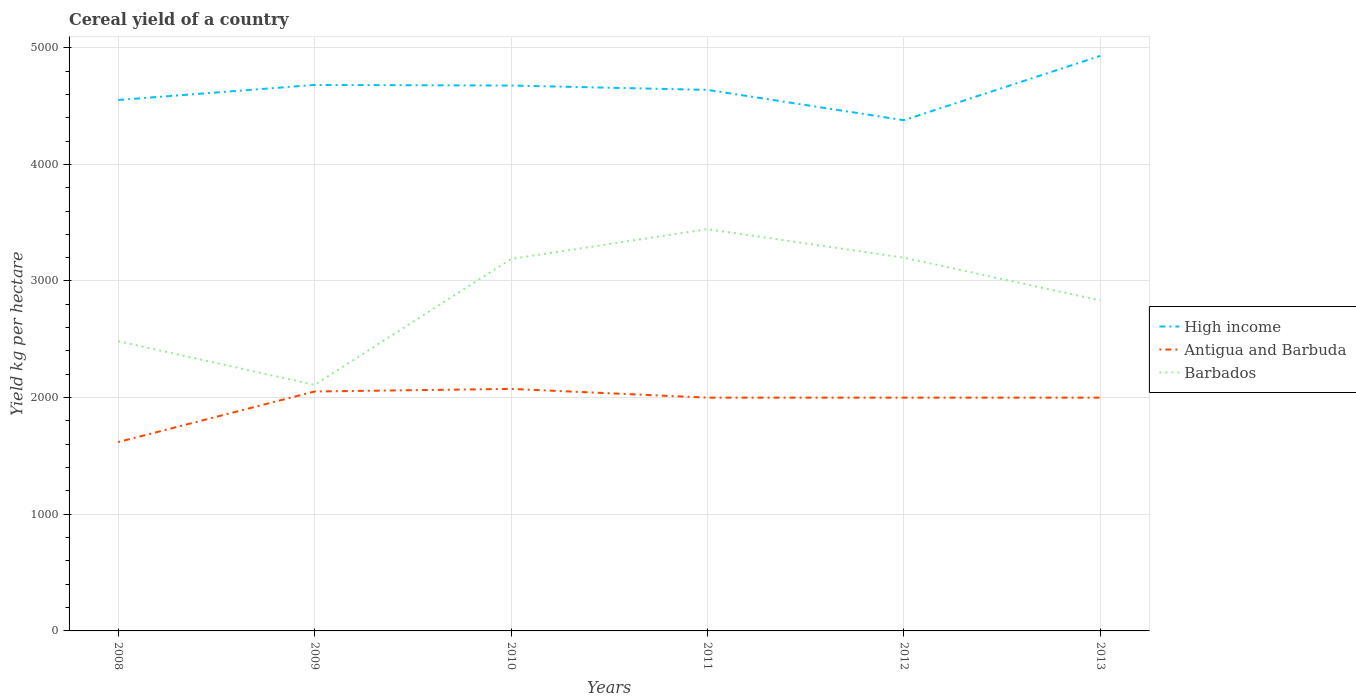How many different coloured lines are there?
Your answer should be very brief. 3. Is the number of lines equal to the number of legend labels?
Make the answer very short. Yes. Across all years, what is the maximum total cereal yield in Antigua and Barbuda?
Provide a succinct answer. 1619.05. In which year was the total cereal yield in High income maximum?
Provide a succinct answer. 2012. What is the total total cereal yield in High income in the graph?
Your answer should be very brief. 302.4. What is the difference between the highest and the second highest total cereal yield in Barbados?
Offer a terse response. 1335.07. How many lines are there?
Make the answer very short. 3. How many years are there in the graph?
Your answer should be compact. 6. What is the difference between two consecutive major ticks on the Y-axis?
Keep it short and to the point. 1000. Does the graph contain any zero values?
Your answer should be compact. No. How many legend labels are there?
Offer a terse response. 3. How are the legend labels stacked?
Your answer should be very brief. Vertical. What is the title of the graph?
Ensure brevity in your answer.  Cereal yield of a country. What is the label or title of the X-axis?
Your answer should be very brief. Years. What is the label or title of the Y-axis?
Offer a very short reply. Yield kg per hectare. What is the Yield kg per hectare in High income in 2008?
Your answer should be very brief. 4551.76. What is the Yield kg per hectare of Antigua and Barbuda in 2008?
Offer a very short reply. 1619.05. What is the Yield kg per hectare of Barbados in 2008?
Give a very brief answer. 2484.21. What is the Yield kg per hectare in High income in 2009?
Offer a very short reply. 4680.84. What is the Yield kg per hectare in Antigua and Barbuda in 2009?
Your answer should be very brief. 2052.63. What is the Yield kg per hectare in Barbados in 2009?
Your response must be concise. 2109.38. What is the Yield kg per hectare in High income in 2010?
Provide a short and direct response. 4675.68. What is the Yield kg per hectare in Antigua and Barbuda in 2010?
Provide a short and direct response. 2075. What is the Yield kg per hectare of Barbados in 2010?
Ensure brevity in your answer.  3188.89. What is the Yield kg per hectare in High income in 2011?
Your answer should be very brief. 4638.49. What is the Yield kg per hectare in Antigua and Barbuda in 2011?
Provide a succinct answer. 2000. What is the Yield kg per hectare in Barbados in 2011?
Offer a terse response. 3444.44. What is the Yield kg per hectare in High income in 2012?
Offer a terse response. 4378.44. What is the Yield kg per hectare in Barbados in 2012?
Give a very brief answer. 3200. What is the Yield kg per hectare of High income in 2013?
Make the answer very short. 4929.93. What is the Yield kg per hectare in Antigua and Barbuda in 2013?
Provide a succinct answer. 2000. What is the Yield kg per hectare in Barbados in 2013?
Your response must be concise. 2833.33. Across all years, what is the maximum Yield kg per hectare of High income?
Your response must be concise. 4929.93. Across all years, what is the maximum Yield kg per hectare in Antigua and Barbuda?
Make the answer very short. 2075. Across all years, what is the maximum Yield kg per hectare of Barbados?
Give a very brief answer. 3444.44. Across all years, what is the minimum Yield kg per hectare of High income?
Provide a succinct answer. 4378.44. Across all years, what is the minimum Yield kg per hectare in Antigua and Barbuda?
Provide a succinct answer. 1619.05. Across all years, what is the minimum Yield kg per hectare in Barbados?
Provide a succinct answer. 2109.38. What is the total Yield kg per hectare in High income in the graph?
Your response must be concise. 2.79e+04. What is the total Yield kg per hectare of Antigua and Barbuda in the graph?
Make the answer very short. 1.17e+04. What is the total Yield kg per hectare of Barbados in the graph?
Make the answer very short. 1.73e+04. What is the difference between the Yield kg per hectare of High income in 2008 and that in 2009?
Make the answer very short. -129.08. What is the difference between the Yield kg per hectare of Antigua and Barbuda in 2008 and that in 2009?
Offer a very short reply. -433.58. What is the difference between the Yield kg per hectare of Barbados in 2008 and that in 2009?
Your response must be concise. 374.84. What is the difference between the Yield kg per hectare in High income in 2008 and that in 2010?
Your answer should be compact. -123.92. What is the difference between the Yield kg per hectare of Antigua and Barbuda in 2008 and that in 2010?
Offer a terse response. -455.95. What is the difference between the Yield kg per hectare in Barbados in 2008 and that in 2010?
Your response must be concise. -704.68. What is the difference between the Yield kg per hectare in High income in 2008 and that in 2011?
Provide a short and direct response. -86.73. What is the difference between the Yield kg per hectare of Antigua and Barbuda in 2008 and that in 2011?
Your answer should be very brief. -380.95. What is the difference between the Yield kg per hectare in Barbados in 2008 and that in 2011?
Your response must be concise. -960.23. What is the difference between the Yield kg per hectare in High income in 2008 and that in 2012?
Offer a terse response. 173.32. What is the difference between the Yield kg per hectare in Antigua and Barbuda in 2008 and that in 2012?
Your response must be concise. -380.95. What is the difference between the Yield kg per hectare in Barbados in 2008 and that in 2012?
Make the answer very short. -715.79. What is the difference between the Yield kg per hectare in High income in 2008 and that in 2013?
Offer a very short reply. -378.17. What is the difference between the Yield kg per hectare in Antigua and Barbuda in 2008 and that in 2013?
Make the answer very short. -380.95. What is the difference between the Yield kg per hectare of Barbados in 2008 and that in 2013?
Keep it short and to the point. -349.12. What is the difference between the Yield kg per hectare of High income in 2009 and that in 2010?
Your answer should be compact. 5.16. What is the difference between the Yield kg per hectare in Antigua and Barbuda in 2009 and that in 2010?
Your answer should be very brief. -22.37. What is the difference between the Yield kg per hectare in Barbados in 2009 and that in 2010?
Give a very brief answer. -1079.51. What is the difference between the Yield kg per hectare in High income in 2009 and that in 2011?
Make the answer very short. 42.35. What is the difference between the Yield kg per hectare in Antigua and Barbuda in 2009 and that in 2011?
Offer a terse response. 52.63. What is the difference between the Yield kg per hectare in Barbados in 2009 and that in 2011?
Your answer should be very brief. -1335.07. What is the difference between the Yield kg per hectare in High income in 2009 and that in 2012?
Keep it short and to the point. 302.4. What is the difference between the Yield kg per hectare in Antigua and Barbuda in 2009 and that in 2012?
Ensure brevity in your answer.  52.63. What is the difference between the Yield kg per hectare of Barbados in 2009 and that in 2012?
Keep it short and to the point. -1090.62. What is the difference between the Yield kg per hectare of High income in 2009 and that in 2013?
Offer a very short reply. -249.09. What is the difference between the Yield kg per hectare in Antigua and Barbuda in 2009 and that in 2013?
Provide a short and direct response. 52.63. What is the difference between the Yield kg per hectare in Barbados in 2009 and that in 2013?
Offer a very short reply. -723.96. What is the difference between the Yield kg per hectare of High income in 2010 and that in 2011?
Ensure brevity in your answer.  37.19. What is the difference between the Yield kg per hectare of Antigua and Barbuda in 2010 and that in 2011?
Make the answer very short. 75. What is the difference between the Yield kg per hectare in Barbados in 2010 and that in 2011?
Offer a very short reply. -255.56. What is the difference between the Yield kg per hectare in High income in 2010 and that in 2012?
Provide a short and direct response. 297.24. What is the difference between the Yield kg per hectare in Barbados in 2010 and that in 2012?
Your answer should be compact. -11.11. What is the difference between the Yield kg per hectare in High income in 2010 and that in 2013?
Your answer should be very brief. -254.25. What is the difference between the Yield kg per hectare in Barbados in 2010 and that in 2013?
Your response must be concise. 355.56. What is the difference between the Yield kg per hectare in High income in 2011 and that in 2012?
Provide a succinct answer. 260.05. What is the difference between the Yield kg per hectare of Antigua and Barbuda in 2011 and that in 2012?
Provide a short and direct response. 0. What is the difference between the Yield kg per hectare in Barbados in 2011 and that in 2012?
Offer a terse response. 244.44. What is the difference between the Yield kg per hectare in High income in 2011 and that in 2013?
Offer a terse response. -291.44. What is the difference between the Yield kg per hectare of Barbados in 2011 and that in 2013?
Keep it short and to the point. 611.11. What is the difference between the Yield kg per hectare in High income in 2012 and that in 2013?
Make the answer very short. -551.49. What is the difference between the Yield kg per hectare of Antigua and Barbuda in 2012 and that in 2013?
Offer a terse response. 0. What is the difference between the Yield kg per hectare in Barbados in 2012 and that in 2013?
Your answer should be compact. 366.67. What is the difference between the Yield kg per hectare in High income in 2008 and the Yield kg per hectare in Antigua and Barbuda in 2009?
Provide a succinct answer. 2499.13. What is the difference between the Yield kg per hectare of High income in 2008 and the Yield kg per hectare of Barbados in 2009?
Keep it short and to the point. 2442.39. What is the difference between the Yield kg per hectare of Antigua and Barbuda in 2008 and the Yield kg per hectare of Barbados in 2009?
Your answer should be compact. -490.33. What is the difference between the Yield kg per hectare of High income in 2008 and the Yield kg per hectare of Antigua and Barbuda in 2010?
Keep it short and to the point. 2476.76. What is the difference between the Yield kg per hectare of High income in 2008 and the Yield kg per hectare of Barbados in 2010?
Offer a terse response. 1362.87. What is the difference between the Yield kg per hectare of Antigua and Barbuda in 2008 and the Yield kg per hectare of Barbados in 2010?
Your answer should be compact. -1569.84. What is the difference between the Yield kg per hectare in High income in 2008 and the Yield kg per hectare in Antigua and Barbuda in 2011?
Offer a very short reply. 2551.76. What is the difference between the Yield kg per hectare of High income in 2008 and the Yield kg per hectare of Barbados in 2011?
Your response must be concise. 1107.32. What is the difference between the Yield kg per hectare of Antigua and Barbuda in 2008 and the Yield kg per hectare of Barbados in 2011?
Offer a terse response. -1825.4. What is the difference between the Yield kg per hectare in High income in 2008 and the Yield kg per hectare in Antigua and Barbuda in 2012?
Give a very brief answer. 2551.76. What is the difference between the Yield kg per hectare of High income in 2008 and the Yield kg per hectare of Barbados in 2012?
Your answer should be compact. 1351.76. What is the difference between the Yield kg per hectare in Antigua and Barbuda in 2008 and the Yield kg per hectare in Barbados in 2012?
Your answer should be compact. -1580.95. What is the difference between the Yield kg per hectare of High income in 2008 and the Yield kg per hectare of Antigua and Barbuda in 2013?
Make the answer very short. 2551.76. What is the difference between the Yield kg per hectare in High income in 2008 and the Yield kg per hectare in Barbados in 2013?
Give a very brief answer. 1718.43. What is the difference between the Yield kg per hectare in Antigua and Barbuda in 2008 and the Yield kg per hectare in Barbados in 2013?
Your answer should be very brief. -1214.29. What is the difference between the Yield kg per hectare of High income in 2009 and the Yield kg per hectare of Antigua and Barbuda in 2010?
Give a very brief answer. 2605.84. What is the difference between the Yield kg per hectare of High income in 2009 and the Yield kg per hectare of Barbados in 2010?
Your answer should be compact. 1491.95. What is the difference between the Yield kg per hectare in Antigua and Barbuda in 2009 and the Yield kg per hectare in Barbados in 2010?
Offer a very short reply. -1136.26. What is the difference between the Yield kg per hectare of High income in 2009 and the Yield kg per hectare of Antigua and Barbuda in 2011?
Keep it short and to the point. 2680.84. What is the difference between the Yield kg per hectare of High income in 2009 and the Yield kg per hectare of Barbados in 2011?
Give a very brief answer. 1236.39. What is the difference between the Yield kg per hectare of Antigua and Barbuda in 2009 and the Yield kg per hectare of Barbados in 2011?
Give a very brief answer. -1391.81. What is the difference between the Yield kg per hectare of High income in 2009 and the Yield kg per hectare of Antigua and Barbuda in 2012?
Provide a succinct answer. 2680.84. What is the difference between the Yield kg per hectare in High income in 2009 and the Yield kg per hectare in Barbados in 2012?
Offer a very short reply. 1480.84. What is the difference between the Yield kg per hectare in Antigua and Barbuda in 2009 and the Yield kg per hectare in Barbados in 2012?
Offer a terse response. -1147.37. What is the difference between the Yield kg per hectare of High income in 2009 and the Yield kg per hectare of Antigua and Barbuda in 2013?
Your answer should be compact. 2680.84. What is the difference between the Yield kg per hectare in High income in 2009 and the Yield kg per hectare in Barbados in 2013?
Your answer should be compact. 1847.5. What is the difference between the Yield kg per hectare in Antigua and Barbuda in 2009 and the Yield kg per hectare in Barbados in 2013?
Ensure brevity in your answer.  -780.7. What is the difference between the Yield kg per hectare of High income in 2010 and the Yield kg per hectare of Antigua and Barbuda in 2011?
Make the answer very short. 2675.68. What is the difference between the Yield kg per hectare in High income in 2010 and the Yield kg per hectare in Barbados in 2011?
Offer a terse response. 1231.23. What is the difference between the Yield kg per hectare in Antigua and Barbuda in 2010 and the Yield kg per hectare in Barbados in 2011?
Your answer should be very brief. -1369.44. What is the difference between the Yield kg per hectare in High income in 2010 and the Yield kg per hectare in Antigua and Barbuda in 2012?
Offer a very short reply. 2675.68. What is the difference between the Yield kg per hectare in High income in 2010 and the Yield kg per hectare in Barbados in 2012?
Keep it short and to the point. 1475.68. What is the difference between the Yield kg per hectare in Antigua and Barbuda in 2010 and the Yield kg per hectare in Barbados in 2012?
Keep it short and to the point. -1125. What is the difference between the Yield kg per hectare in High income in 2010 and the Yield kg per hectare in Antigua and Barbuda in 2013?
Make the answer very short. 2675.68. What is the difference between the Yield kg per hectare of High income in 2010 and the Yield kg per hectare of Barbados in 2013?
Give a very brief answer. 1842.34. What is the difference between the Yield kg per hectare of Antigua and Barbuda in 2010 and the Yield kg per hectare of Barbados in 2013?
Ensure brevity in your answer.  -758.33. What is the difference between the Yield kg per hectare in High income in 2011 and the Yield kg per hectare in Antigua and Barbuda in 2012?
Your answer should be very brief. 2638.49. What is the difference between the Yield kg per hectare in High income in 2011 and the Yield kg per hectare in Barbados in 2012?
Offer a terse response. 1438.49. What is the difference between the Yield kg per hectare in Antigua and Barbuda in 2011 and the Yield kg per hectare in Barbados in 2012?
Offer a terse response. -1200. What is the difference between the Yield kg per hectare in High income in 2011 and the Yield kg per hectare in Antigua and Barbuda in 2013?
Offer a terse response. 2638.49. What is the difference between the Yield kg per hectare of High income in 2011 and the Yield kg per hectare of Barbados in 2013?
Give a very brief answer. 1805.16. What is the difference between the Yield kg per hectare of Antigua and Barbuda in 2011 and the Yield kg per hectare of Barbados in 2013?
Your response must be concise. -833.33. What is the difference between the Yield kg per hectare of High income in 2012 and the Yield kg per hectare of Antigua and Barbuda in 2013?
Ensure brevity in your answer.  2378.44. What is the difference between the Yield kg per hectare of High income in 2012 and the Yield kg per hectare of Barbados in 2013?
Give a very brief answer. 1545.1. What is the difference between the Yield kg per hectare of Antigua and Barbuda in 2012 and the Yield kg per hectare of Barbados in 2013?
Make the answer very short. -833.33. What is the average Yield kg per hectare in High income per year?
Provide a short and direct response. 4642.52. What is the average Yield kg per hectare in Antigua and Barbuda per year?
Your answer should be very brief. 1957.78. What is the average Yield kg per hectare in Barbados per year?
Your answer should be compact. 2876.71. In the year 2008, what is the difference between the Yield kg per hectare in High income and Yield kg per hectare in Antigua and Barbuda?
Ensure brevity in your answer.  2932.71. In the year 2008, what is the difference between the Yield kg per hectare in High income and Yield kg per hectare in Barbados?
Your answer should be compact. 2067.55. In the year 2008, what is the difference between the Yield kg per hectare of Antigua and Barbuda and Yield kg per hectare of Barbados?
Give a very brief answer. -865.16. In the year 2009, what is the difference between the Yield kg per hectare of High income and Yield kg per hectare of Antigua and Barbuda?
Your answer should be compact. 2628.2. In the year 2009, what is the difference between the Yield kg per hectare of High income and Yield kg per hectare of Barbados?
Ensure brevity in your answer.  2571.46. In the year 2009, what is the difference between the Yield kg per hectare in Antigua and Barbuda and Yield kg per hectare in Barbados?
Your answer should be very brief. -56.74. In the year 2010, what is the difference between the Yield kg per hectare of High income and Yield kg per hectare of Antigua and Barbuda?
Provide a short and direct response. 2600.68. In the year 2010, what is the difference between the Yield kg per hectare of High income and Yield kg per hectare of Barbados?
Give a very brief answer. 1486.79. In the year 2010, what is the difference between the Yield kg per hectare in Antigua and Barbuda and Yield kg per hectare in Barbados?
Offer a terse response. -1113.89. In the year 2011, what is the difference between the Yield kg per hectare of High income and Yield kg per hectare of Antigua and Barbuda?
Your answer should be compact. 2638.49. In the year 2011, what is the difference between the Yield kg per hectare in High income and Yield kg per hectare in Barbados?
Your answer should be very brief. 1194.05. In the year 2011, what is the difference between the Yield kg per hectare of Antigua and Barbuda and Yield kg per hectare of Barbados?
Offer a terse response. -1444.44. In the year 2012, what is the difference between the Yield kg per hectare of High income and Yield kg per hectare of Antigua and Barbuda?
Provide a succinct answer. 2378.44. In the year 2012, what is the difference between the Yield kg per hectare in High income and Yield kg per hectare in Barbados?
Ensure brevity in your answer.  1178.44. In the year 2012, what is the difference between the Yield kg per hectare in Antigua and Barbuda and Yield kg per hectare in Barbados?
Make the answer very short. -1200. In the year 2013, what is the difference between the Yield kg per hectare of High income and Yield kg per hectare of Antigua and Barbuda?
Your answer should be compact. 2929.93. In the year 2013, what is the difference between the Yield kg per hectare in High income and Yield kg per hectare in Barbados?
Offer a very short reply. 2096.6. In the year 2013, what is the difference between the Yield kg per hectare in Antigua and Barbuda and Yield kg per hectare in Barbados?
Make the answer very short. -833.33. What is the ratio of the Yield kg per hectare in High income in 2008 to that in 2009?
Offer a terse response. 0.97. What is the ratio of the Yield kg per hectare in Antigua and Barbuda in 2008 to that in 2009?
Ensure brevity in your answer.  0.79. What is the ratio of the Yield kg per hectare in Barbados in 2008 to that in 2009?
Make the answer very short. 1.18. What is the ratio of the Yield kg per hectare of High income in 2008 to that in 2010?
Ensure brevity in your answer.  0.97. What is the ratio of the Yield kg per hectare of Antigua and Barbuda in 2008 to that in 2010?
Give a very brief answer. 0.78. What is the ratio of the Yield kg per hectare of Barbados in 2008 to that in 2010?
Your response must be concise. 0.78. What is the ratio of the Yield kg per hectare of High income in 2008 to that in 2011?
Ensure brevity in your answer.  0.98. What is the ratio of the Yield kg per hectare in Antigua and Barbuda in 2008 to that in 2011?
Ensure brevity in your answer.  0.81. What is the ratio of the Yield kg per hectare in Barbados in 2008 to that in 2011?
Make the answer very short. 0.72. What is the ratio of the Yield kg per hectare in High income in 2008 to that in 2012?
Your answer should be compact. 1.04. What is the ratio of the Yield kg per hectare in Antigua and Barbuda in 2008 to that in 2012?
Offer a very short reply. 0.81. What is the ratio of the Yield kg per hectare of Barbados in 2008 to that in 2012?
Provide a succinct answer. 0.78. What is the ratio of the Yield kg per hectare in High income in 2008 to that in 2013?
Offer a terse response. 0.92. What is the ratio of the Yield kg per hectare in Antigua and Barbuda in 2008 to that in 2013?
Your answer should be very brief. 0.81. What is the ratio of the Yield kg per hectare in Barbados in 2008 to that in 2013?
Your answer should be very brief. 0.88. What is the ratio of the Yield kg per hectare in Antigua and Barbuda in 2009 to that in 2010?
Offer a very short reply. 0.99. What is the ratio of the Yield kg per hectare in Barbados in 2009 to that in 2010?
Your answer should be compact. 0.66. What is the ratio of the Yield kg per hectare in High income in 2009 to that in 2011?
Provide a succinct answer. 1.01. What is the ratio of the Yield kg per hectare of Antigua and Barbuda in 2009 to that in 2011?
Keep it short and to the point. 1.03. What is the ratio of the Yield kg per hectare in Barbados in 2009 to that in 2011?
Offer a very short reply. 0.61. What is the ratio of the Yield kg per hectare of High income in 2009 to that in 2012?
Offer a very short reply. 1.07. What is the ratio of the Yield kg per hectare in Antigua and Barbuda in 2009 to that in 2012?
Offer a very short reply. 1.03. What is the ratio of the Yield kg per hectare of Barbados in 2009 to that in 2012?
Offer a very short reply. 0.66. What is the ratio of the Yield kg per hectare of High income in 2009 to that in 2013?
Provide a succinct answer. 0.95. What is the ratio of the Yield kg per hectare of Antigua and Barbuda in 2009 to that in 2013?
Give a very brief answer. 1.03. What is the ratio of the Yield kg per hectare of Barbados in 2009 to that in 2013?
Offer a terse response. 0.74. What is the ratio of the Yield kg per hectare of High income in 2010 to that in 2011?
Offer a terse response. 1.01. What is the ratio of the Yield kg per hectare of Antigua and Barbuda in 2010 to that in 2011?
Ensure brevity in your answer.  1.04. What is the ratio of the Yield kg per hectare in Barbados in 2010 to that in 2011?
Ensure brevity in your answer.  0.93. What is the ratio of the Yield kg per hectare in High income in 2010 to that in 2012?
Provide a succinct answer. 1.07. What is the ratio of the Yield kg per hectare in Antigua and Barbuda in 2010 to that in 2012?
Your answer should be very brief. 1.04. What is the ratio of the Yield kg per hectare of Barbados in 2010 to that in 2012?
Give a very brief answer. 1. What is the ratio of the Yield kg per hectare in High income in 2010 to that in 2013?
Make the answer very short. 0.95. What is the ratio of the Yield kg per hectare in Antigua and Barbuda in 2010 to that in 2013?
Your response must be concise. 1.04. What is the ratio of the Yield kg per hectare in Barbados in 2010 to that in 2013?
Give a very brief answer. 1.13. What is the ratio of the Yield kg per hectare of High income in 2011 to that in 2012?
Your response must be concise. 1.06. What is the ratio of the Yield kg per hectare in Barbados in 2011 to that in 2012?
Ensure brevity in your answer.  1.08. What is the ratio of the Yield kg per hectare in High income in 2011 to that in 2013?
Offer a terse response. 0.94. What is the ratio of the Yield kg per hectare in Barbados in 2011 to that in 2013?
Your response must be concise. 1.22. What is the ratio of the Yield kg per hectare of High income in 2012 to that in 2013?
Your answer should be very brief. 0.89. What is the ratio of the Yield kg per hectare in Antigua and Barbuda in 2012 to that in 2013?
Your answer should be very brief. 1. What is the ratio of the Yield kg per hectare of Barbados in 2012 to that in 2013?
Keep it short and to the point. 1.13. What is the difference between the highest and the second highest Yield kg per hectare of High income?
Your response must be concise. 249.09. What is the difference between the highest and the second highest Yield kg per hectare in Antigua and Barbuda?
Your response must be concise. 22.37. What is the difference between the highest and the second highest Yield kg per hectare in Barbados?
Keep it short and to the point. 244.44. What is the difference between the highest and the lowest Yield kg per hectare in High income?
Provide a succinct answer. 551.49. What is the difference between the highest and the lowest Yield kg per hectare of Antigua and Barbuda?
Offer a very short reply. 455.95. What is the difference between the highest and the lowest Yield kg per hectare of Barbados?
Your answer should be very brief. 1335.07. 